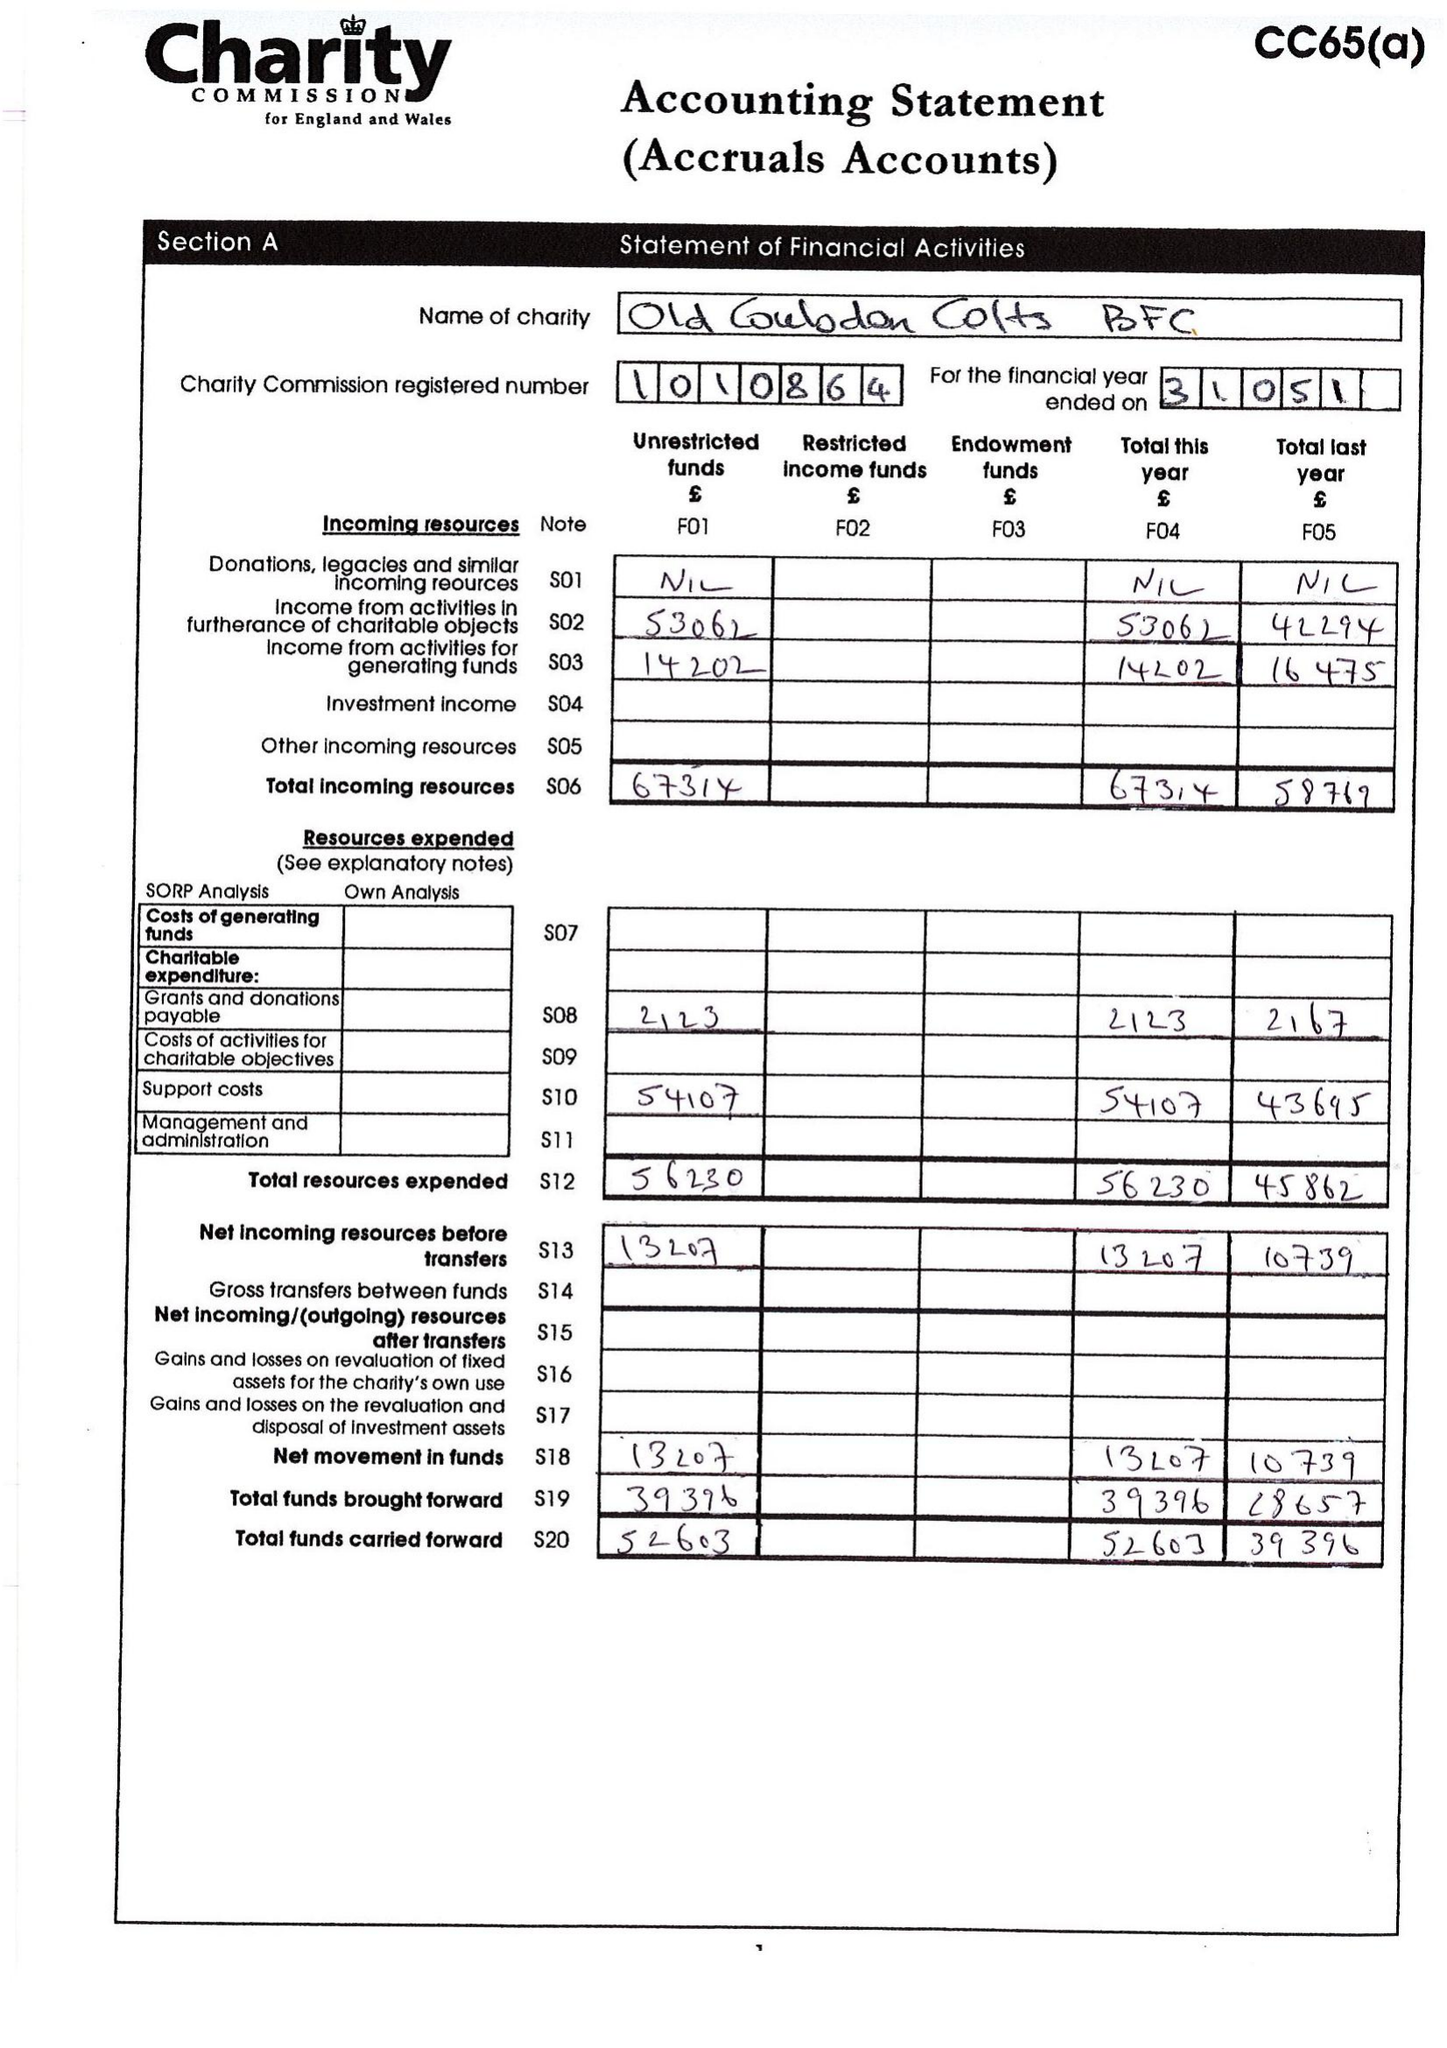What is the value for the report_date?
Answer the question using a single word or phrase. 2015-05-31 